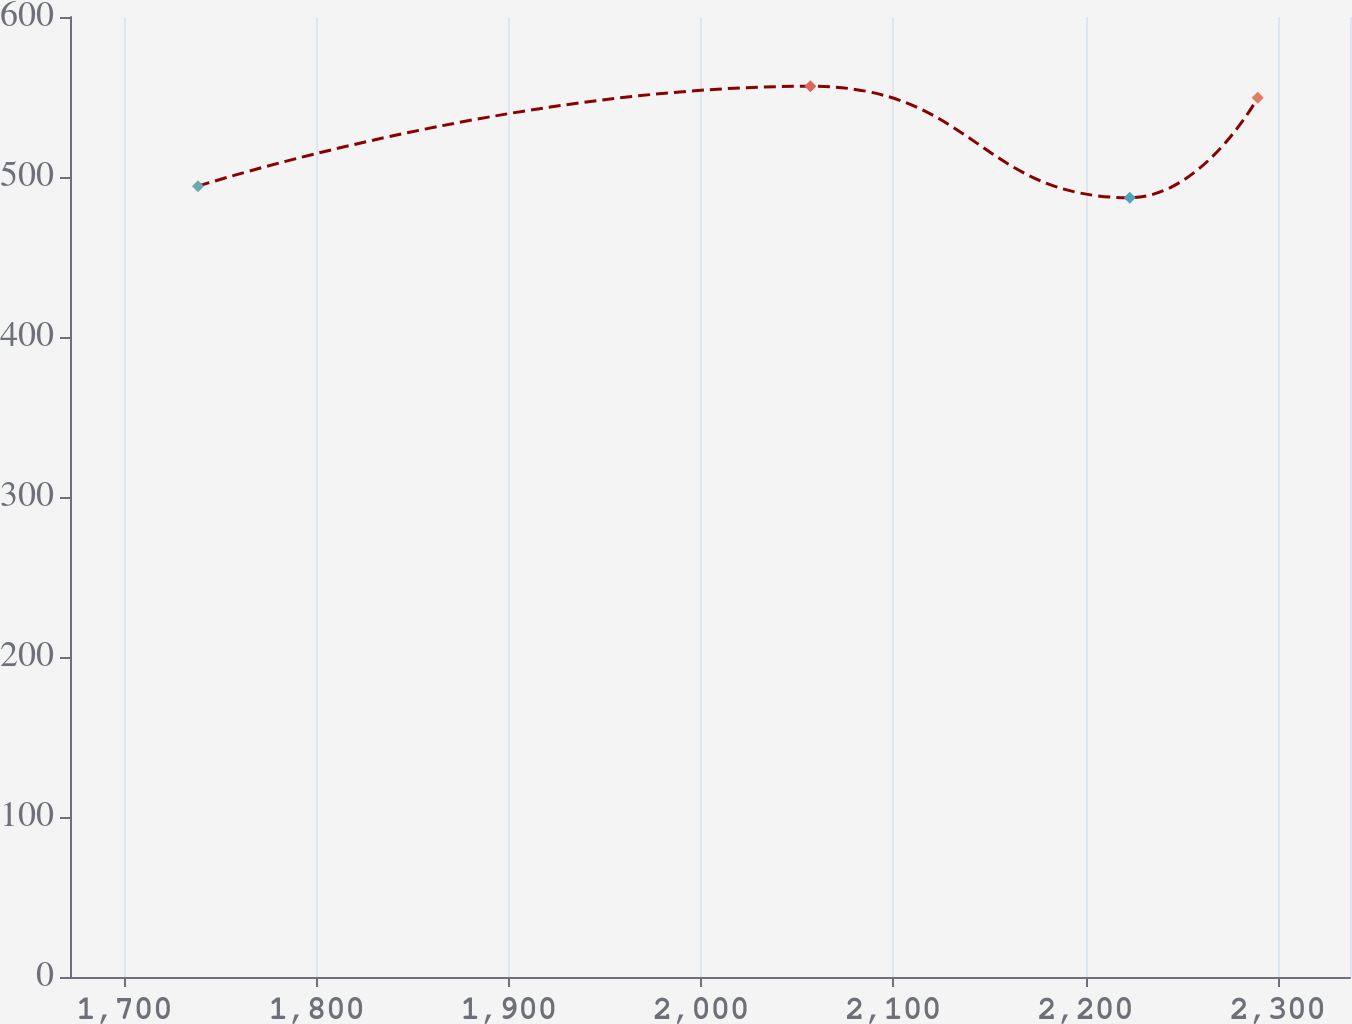Convert chart. <chart><loc_0><loc_0><loc_500><loc_500><line_chart><ecel><fcel>Unnamed: 1<nl><fcel>1738.27<fcel>494.27<nl><fcel>2056.87<fcel>556.73<nl><fcel>2223.03<fcel>487.07<nl><fcel>2289.62<fcel>549.53<nl><fcel>2404.2<fcel>563.93<nl></chart> 